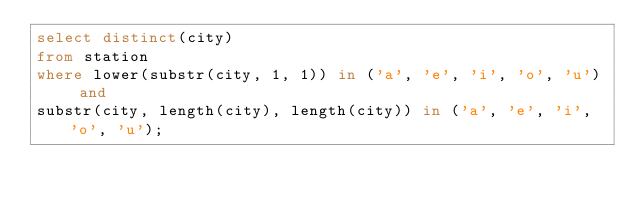<code> <loc_0><loc_0><loc_500><loc_500><_SQL_>select distinct(city)
from station
where lower(substr(city, 1, 1)) in ('a', 'e', 'i', 'o', 'u') and
substr(city, length(city), length(city)) in ('a', 'e', 'i', 'o', 'u');</code> 